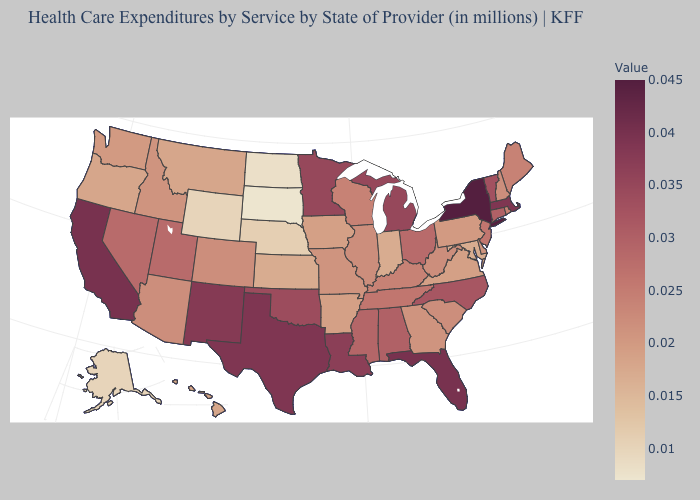Does Oklahoma have a lower value than Colorado?
Keep it brief. No. Does the map have missing data?
Keep it brief. No. Does New York have the lowest value in the Northeast?
Concise answer only. No. Does Michigan have the highest value in the MidWest?
Write a very short answer. Yes. Does New York have the highest value in the USA?
Short answer required. Yes. Does South Dakota have the lowest value in the MidWest?
Answer briefly. Yes. 